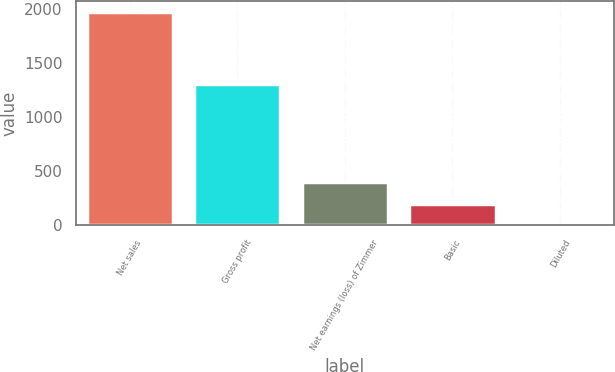Convert chart to OTSL. <chart><loc_0><loc_0><loc_500><loc_500><bar_chart><fcel>Net sales<fcel>Gross profit<fcel>Net earnings (loss) of Zimmer<fcel>Basic<fcel>Diluted<nl><fcel>1972.4<fcel>1307.5<fcel>395.65<fcel>198.56<fcel>1.47<nl></chart> 